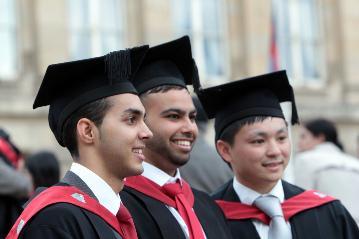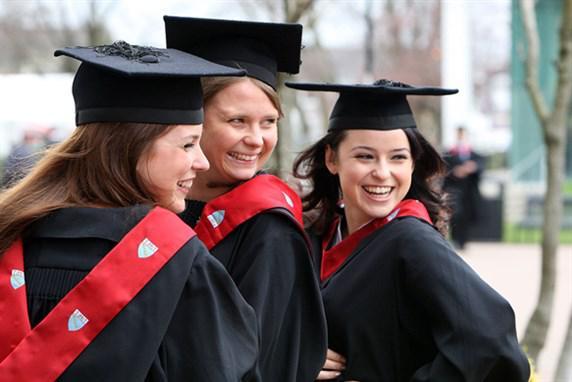The first image is the image on the left, the second image is the image on the right. For the images displayed, is the sentence "An image shows three female graduates posing together wearing black grad caps." factually correct? Answer yes or no. Yes. The first image is the image on the left, the second image is the image on the right. Assess this claim about the two images: "Each image shows at least three graduates standing together wearing black gowns with red trim and black mortarboards". Correct or not? Answer yes or no. Yes. 